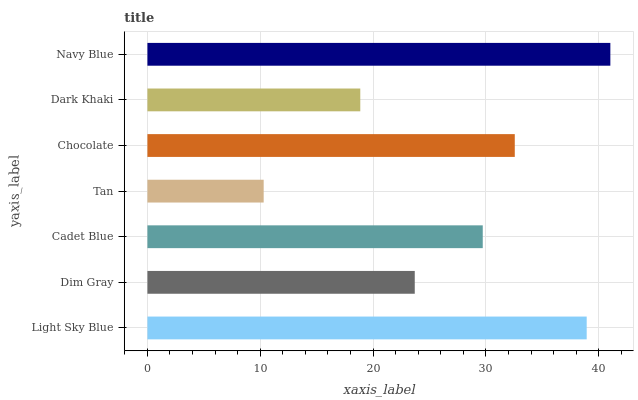Is Tan the minimum?
Answer yes or no. Yes. Is Navy Blue the maximum?
Answer yes or no. Yes. Is Dim Gray the minimum?
Answer yes or no. No. Is Dim Gray the maximum?
Answer yes or no. No. Is Light Sky Blue greater than Dim Gray?
Answer yes or no. Yes. Is Dim Gray less than Light Sky Blue?
Answer yes or no. Yes. Is Dim Gray greater than Light Sky Blue?
Answer yes or no. No. Is Light Sky Blue less than Dim Gray?
Answer yes or no. No. Is Cadet Blue the high median?
Answer yes or no. Yes. Is Cadet Blue the low median?
Answer yes or no. Yes. Is Chocolate the high median?
Answer yes or no. No. Is Chocolate the low median?
Answer yes or no. No. 